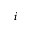Convert formula to latex. <formula><loc_0><loc_0><loc_500><loc_500>i</formula> 